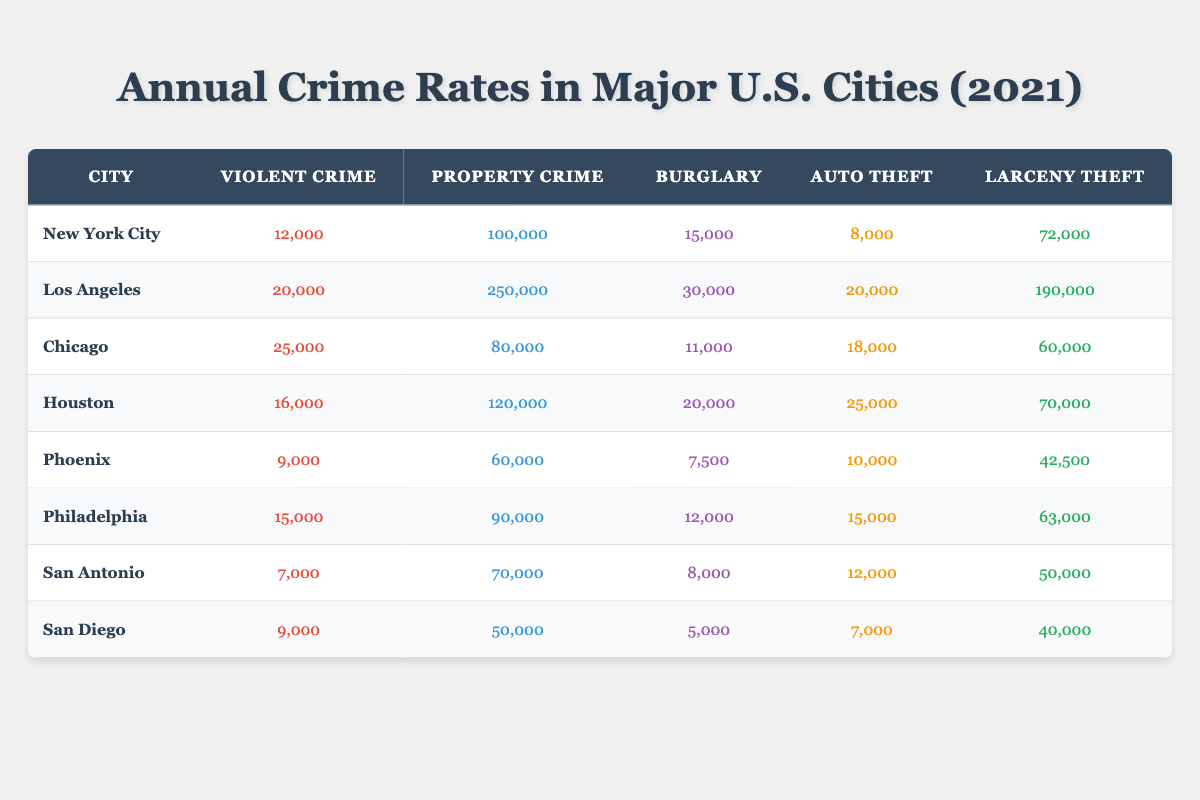What is the violent crime rate in Los Angeles for the year 2021? The table lists the data for Los Angeles under the "Violent Crime" column for the year 2021, which shows 20,000 incidents.
Answer: 20,000 Which city has the highest property crime rate in 2021? By looking at the "Property Crime" column, the highest value is 250,000, which corresponds to Los Angeles.
Answer: Los Angeles How many more violent crimes were reported in Chicago compared to San Antonio? Chicago's violent crime count is 25,000 and San Antonio's is 7,000. The difference is calculated as 25,000 - 7,000 = 18,000.
Answer: 18,000 What is the total number of burglaries across all the cities listed for 2021? To find the total number of burglaries, sum the burglary counts from each city: 15,000 + 30,000 + 11,000 + 20,000 + 7,500 + 12,000 + 8,000 + 5,000 = 108,500.
Answer: 108,500 Is the auto theft rate in Houston higher than in San Diego? Houston has an auto theft count of 25,000, while San Diego has 7,000. Since 25,000 is greater than 7,000, the statement is true.
Answer: Yes What is the average larceny theft rate across all cities for 2021? The larceny theft values are: 72,000 (NYC), 190,000 (LA), 60,000 (Chicago), 70,000 (Houston), 42,500 (Phoenix), 63,000 (Philadelphia), 50,000 (San Antonio), and 40,000 (San Diego). Summing these values gives 623,500. There are 8 cities, so the average is 623,500 / 8 = 77,937.5.
Answer: 77,937.5 Which city has the lowest number of reported violent crimes? By checking the "Violent Crime" column, San Antonio has the lowest number at 7,000, which is less than all the other cities.
Answer: San Antonio If the total number of property crimes in Philadelphia and Phoenix is combined, do they exceed 150,000? The property crime counts are 90,000 for Philadelphia and 60,000 for Phoenix. Their combined total is 90,000 + 60,000 = 150,000, which does not exceed 150,000 but is equal to it.
Answer: No How does the burglary rate in New York City compare to the average burglary rate across these cities? New York City's burglary rate is 15,000. The average is calculated as (15,000 + 30,000 + 11,000 + 20,000 + 7,500 + 12,000 + 8,000 + 5,000) / 8 = 13,250. Comparing the two, 15,000 is higher than 13,250, indicating a higher rate for NYC.
Answer: Higher 